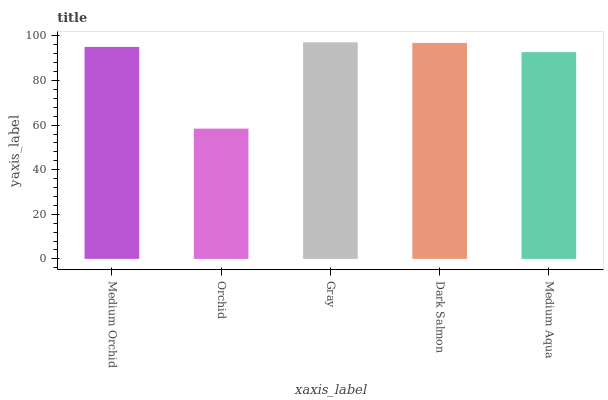Is Orchid the minimum?
Answer yes or no. Yes. Is Gray the maximum?
Answer yes or no. Yes. Is Gray the minimum?
Answer yes or no. No. Is Orchid the maximum?
Answer yes or no. No. Is Gray greater than Orchid?
Answer yes or no. Yes. Is Orchid less than Gray?
Answer yes or no. Yes. Is Orchid greater than Gray?
Answer yes or no. No. Is Gray less than Orchid?
Answer yes or no. No. Is Medium Orchid the high median?
Answer yes or no. Yes. Is Medium Orchid the low median?
Answer yes or no. Yes. Is Gray the high median?
Answer yes or no. No. Is Gray the low median?
Answer yes or no. No. 